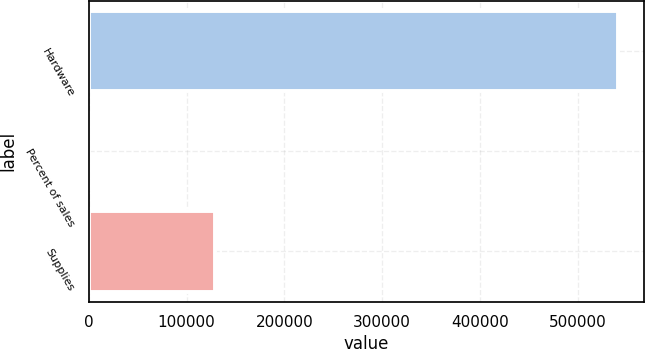Convert chart. <chart><loc_0><loc_0><loc_500><loc_500><bar_chart><fcel>Hardware<fcel>Percent of sales<fcel>Supplies<nl><fcel>540679<fcel>77<fcel>129183<nl></chart> 